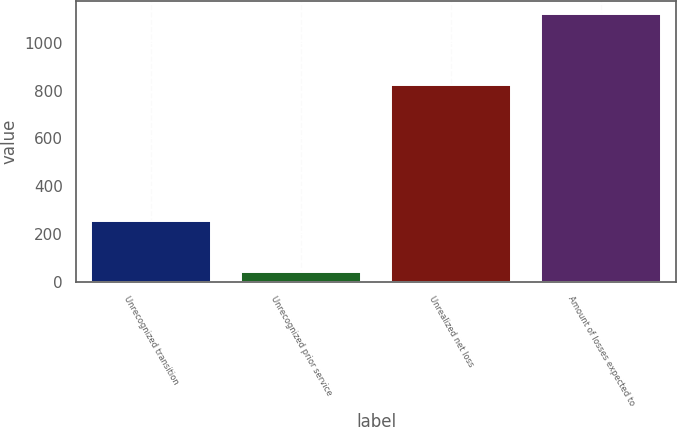Convert chart to OTSL. <chart><loc_0><loc_0><loc_500><loc_500><bar_chart><fcel>Unrecognized transition<fcel>Unrecognized prior service<fcel>Unrealized net loss<fcel>Amount of losses expected to<nl><fcel>255<fcel>42<fcel>824<fcel>1121<nl></chart> 